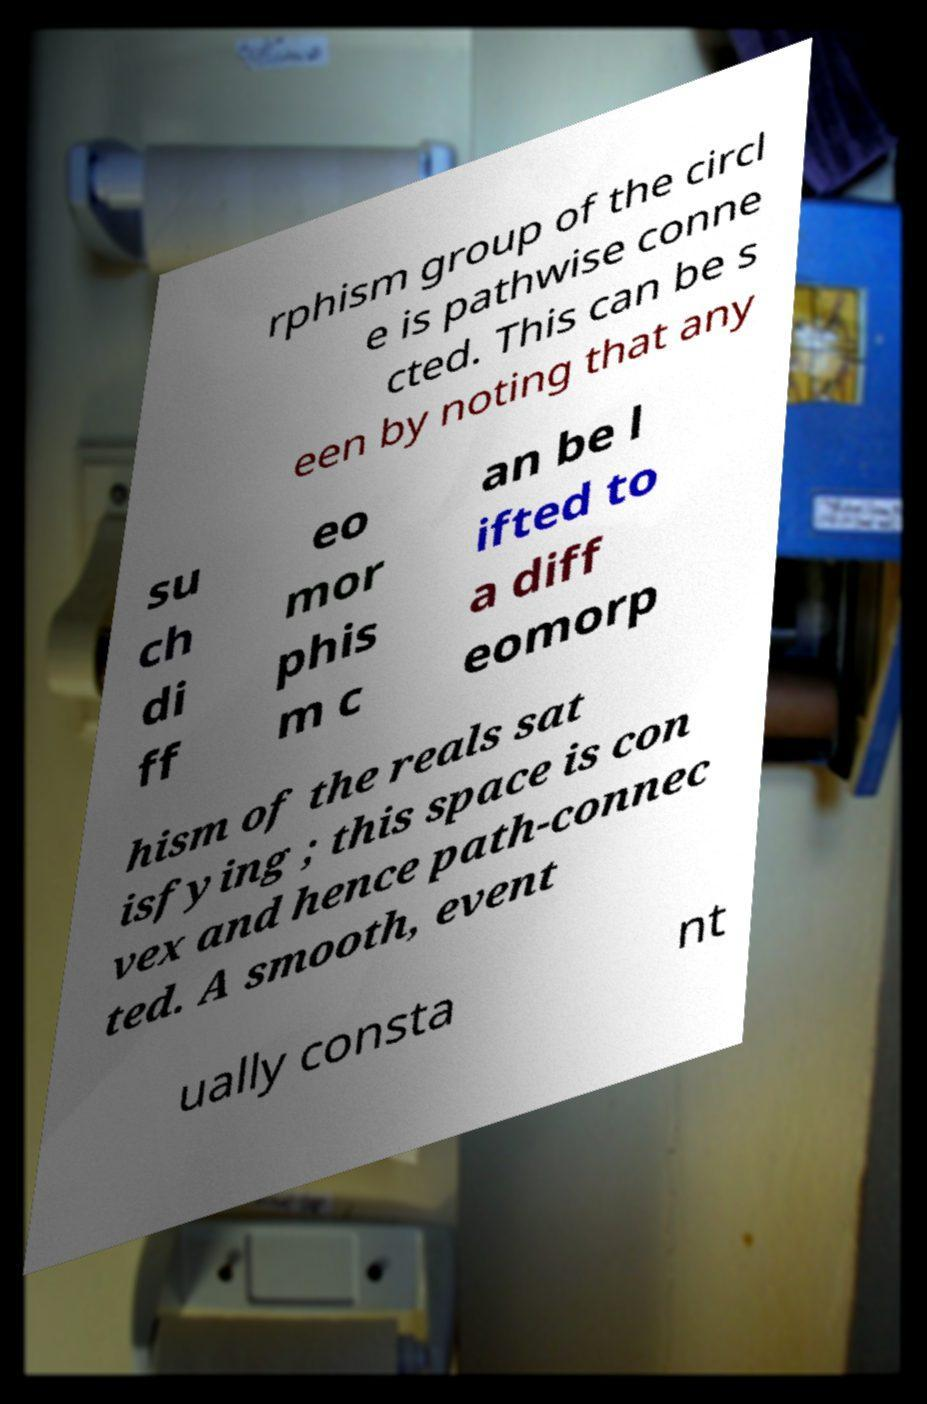Could you assist in decoding the text presented in this image and type it out clearly? rphism group of the circl e is pathwise conne cted. This can be s een by noting that any su ch di ff eo mor phis m c an be l ifted to a diff eomorp hism of the reals sat isfying ; this space is con vex and hence path-connec ted. A smooth, event ually consta nt 